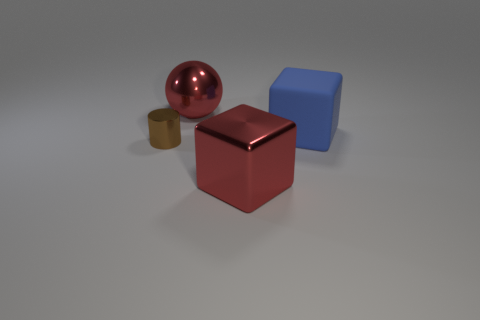Are there any other things that are the same material as the big blue cube?
Make the answer very short. No. There is a large red metal thing that is behind the matte thing that is in front of the red shiny ball; what is its shape?
Your response must be concise. Sphere. There is a red shiny object that is the same size as the red metallic sphere; what is its shape?
Your answer should be very brief. Cube. Is there a shiny thing of the same shape as the big rubber object?
Your answer should be very brief. Yes. What is the blue object made of?
Make the answer very short. Rubber. Are there any small brown cylinders in front of the cylinder?
Offer a very short reply. No. How many red blocks are to the left of the large red object behind the small brown cylinder?
Make the answer very short. 0. There is a ball that is the same size as the red shiny cube; what is it made of?
Offer a terse response. Metal. How many other objects are there of the same material as the tiny brown object?
Make the answer very short. 2. How many large red metal objects are behind the small thing?
Keep it short and to the point. 1. 